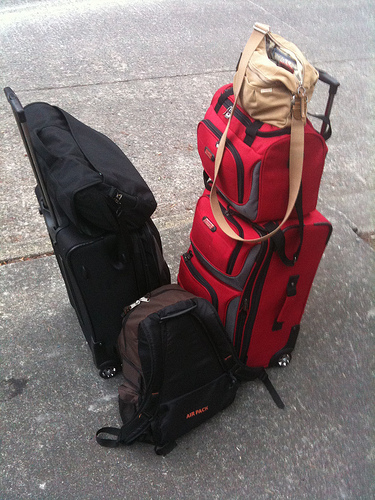Please provide a short description for this region: [0.5, 0.23, 0.79, 0.43]. The region contains a small red suitcase, compact and neatly positioned on top of a stack of other luggage, contributing to an optimized use of travel space. 